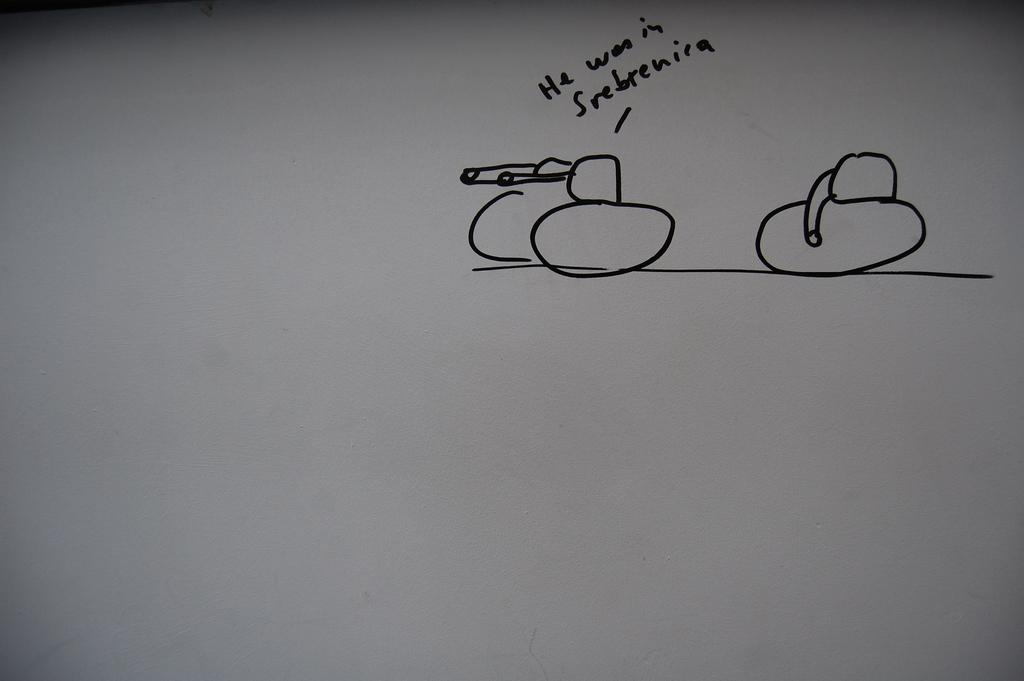<image>
Provide a brief description of the given image. A cartoon of two tanks or two phallic symbols that says He was in Srebrenira. 